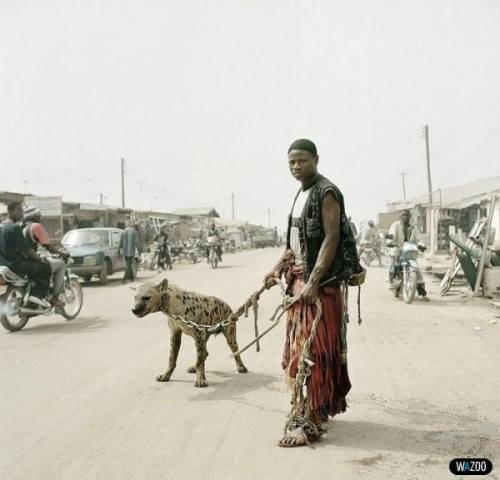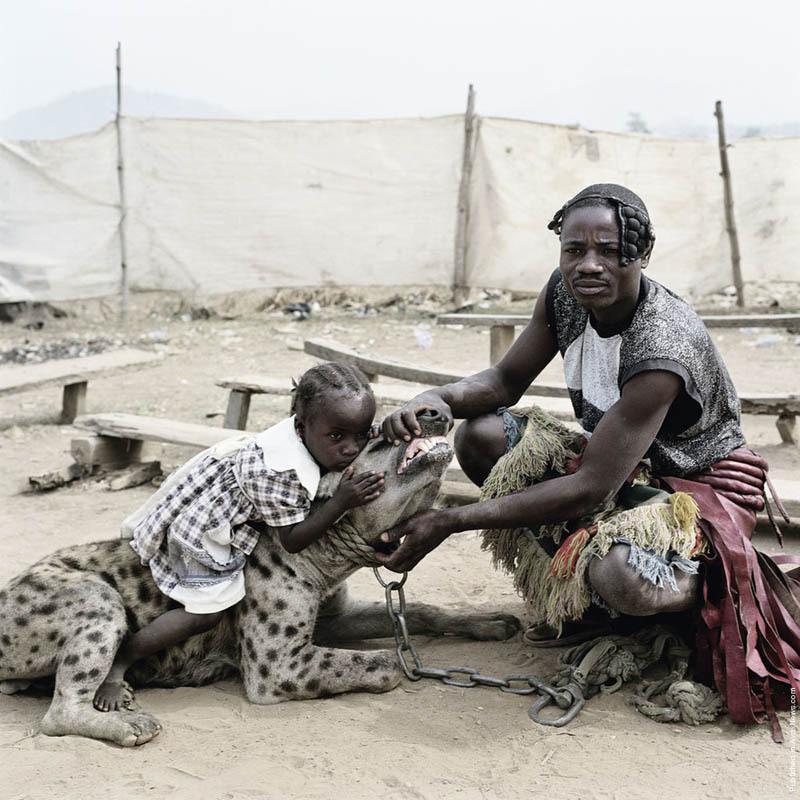The first image is the image on the left, the second image is the image on the right. Analyze the images presented: Is the assertion "There are at least two people in the image on the right." valid? Answer yes or no. Yes. The first image is the image on the left, the second image is the image on the right. Given the left and right images, does the statement "An image shows a man standing with a hyena that is on all fours." hold true? Answer yes or no. Yes. 